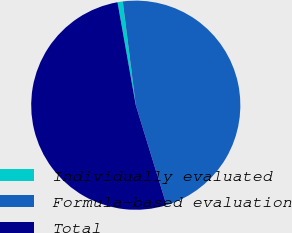Convert chart. <chart><loc_0><loc_0><loc_500><loc_500><pie_chart><fcel>Individually evaluated<fcel>Formula-based evaluation<fcel>Total<nl><fcel>0.81%<fcel>47.24%<fcel>51.96%<nl></chart> 